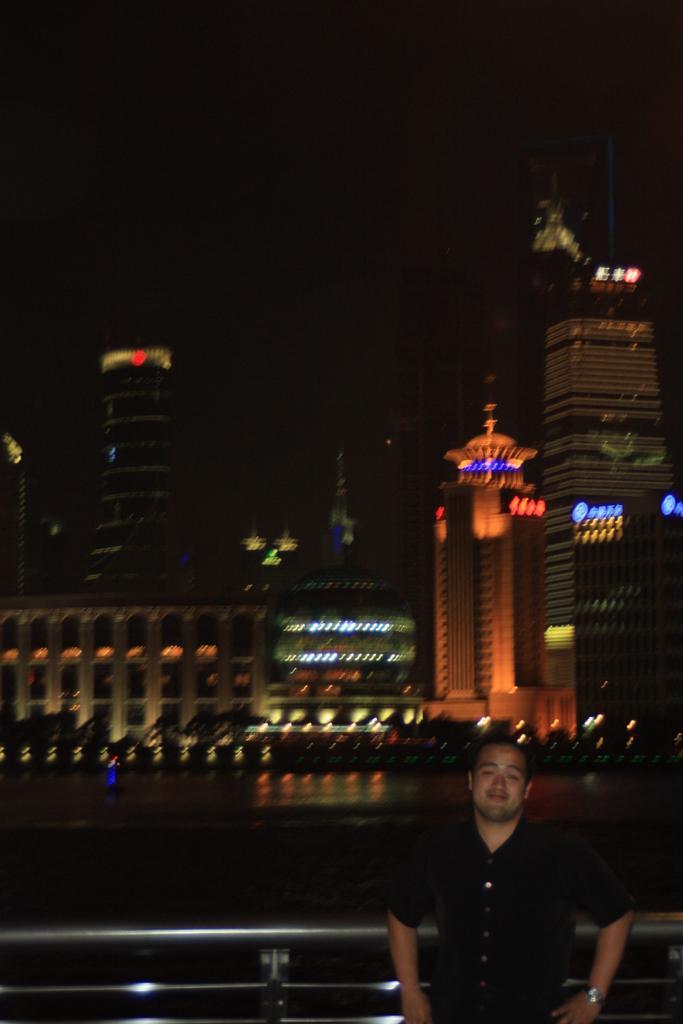Describe this image in one or two sentences. There is a man standing and smiling, behind him we can see fence. In the background we can see buildings, lights and it is dark. 